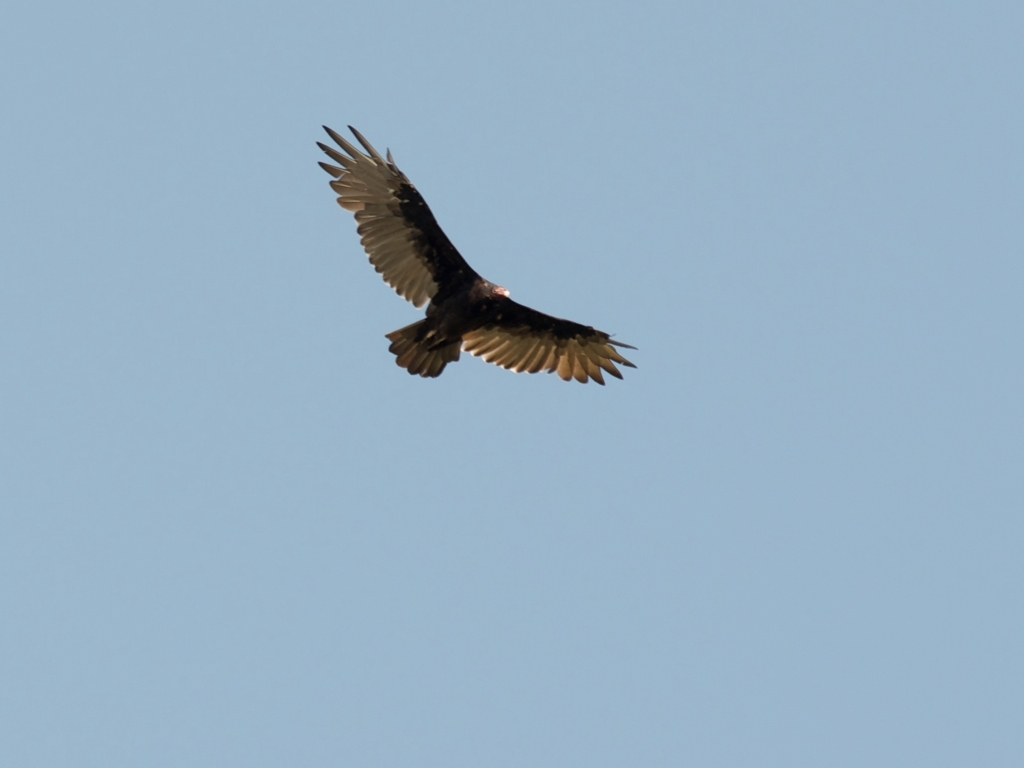What kind of motion or activity does the bird's posture suggest? The bird's wings are spread wide and slightly downwards, which is typically associated with gliding or soaring. This posture maximizes the bird's surface area to catch thermals or updrafts, allowing it to conserve energy while maintaining altitude. There's a sense of gentle motion and stability conveyed by this position, suggesting the bird is either searching for prey from above or simply enjoying the currents and the view. 